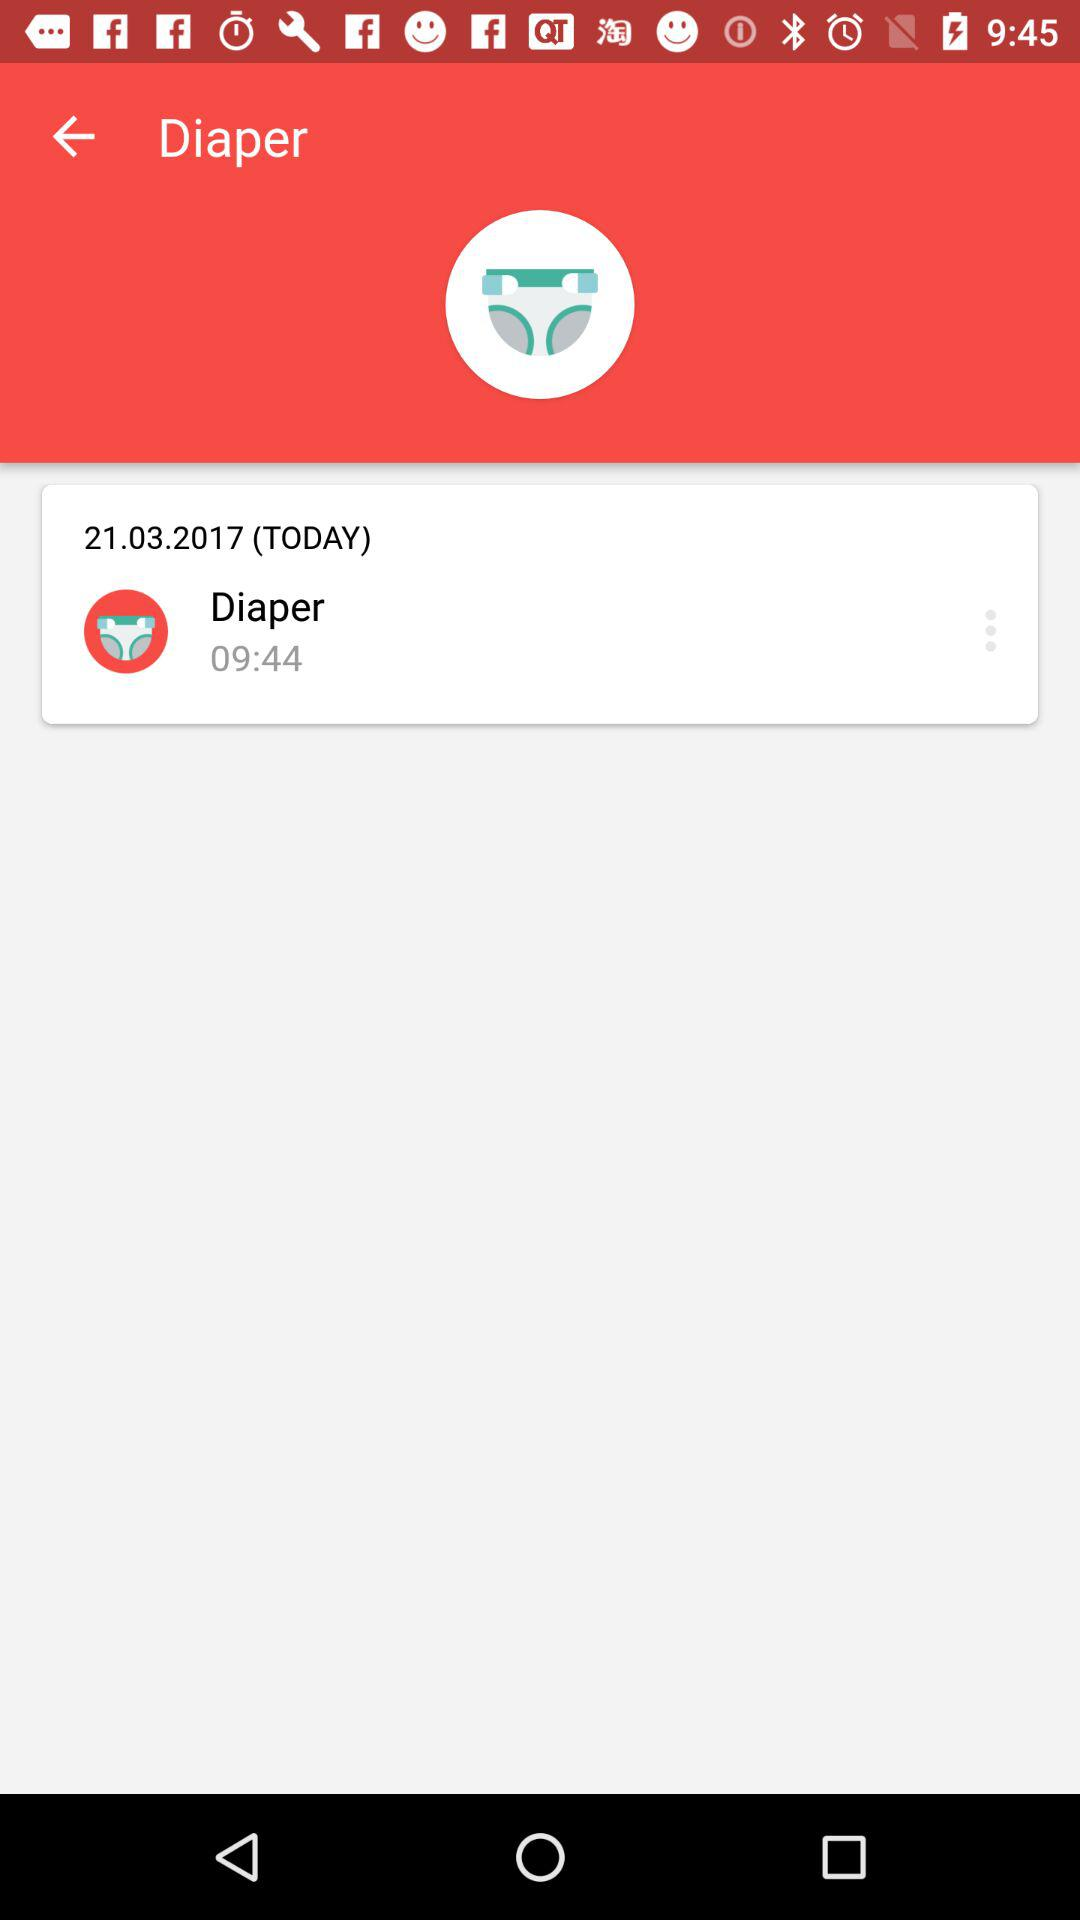What is the time shown on the screen? The time shown on the screen is 09:44. 